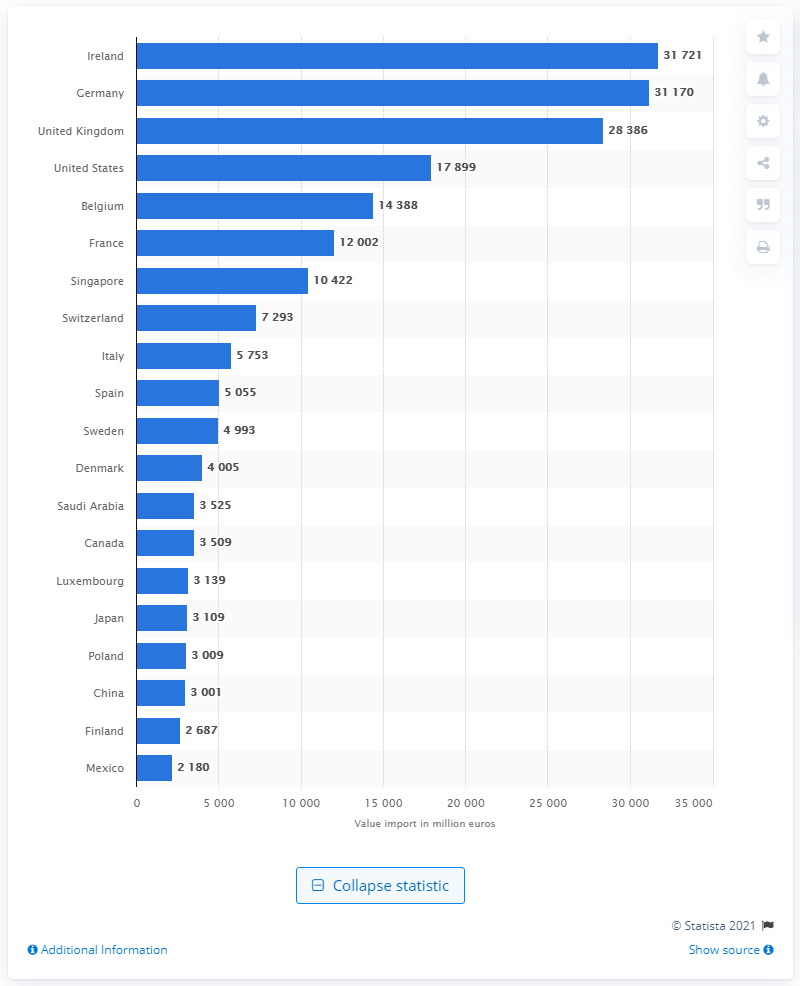What was the value of service exports to the U.S. in the same year? In 2021, the value of service exports to the U.S. was 17,899 million euros, as indicated clearly on the bar chart provided, where the United States is ranked among the top recipients of service exports for that year. 